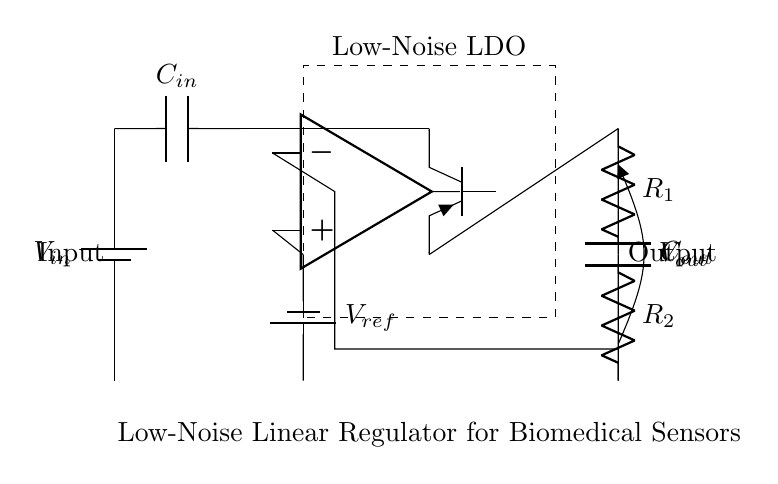What type of regulator is shown in the circuit? The circuit diagram depicts a low-noise linear regulator which is indicated by the labeled box containing "Low-Noise LDO".
Answer: low-noise linear regulator What is the function of the input capacitor? The input capacitor (labeled C_in) stabilizes the input voltage by filtering high-frequency noise, which is essential in maintaining a clean power source for the regulator.
Answer: stabilizing voltage What is the reference voltage in the circuit? The reference voltage is indicated by the component labeled V_ref, which sources a stable voltage for the error amplifier.
Answer: V_ref What are the two resistors in the feedback network? The feedback network consists of resistors labeled R_1 and R_2. They are used to set the output voltage by creating a voltage divider that feeds back into the error amplifier.
Answer: R_1 and R_2 How does the error amplifier affect the output? The error amplifier compares the output voltage with the reference voltage and adjusts the pass transistor to maintain a consistent output voltage despite variations in the load or input.
Answer: regulates output voltage Which component primarily regulates the current flow in this circuit? The main component that regulates current flow is the pass transistor, labeled as Tpnp, which operates under the control of the error amplifier to maintain the desired output voltage level.
Answer: pass transistor What is the purpose of the output capacitor? The output capacitor (labeled C_out) is used to filter the output voltage, reducing transient response and noise, thereby providing a stable voltage to sensitive biomedical sensors.
Answer: smoothing output voltage 